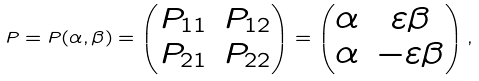Convert formula to latex. <formula><loc_0><loc_0><loc_500><loc_500>P = P ( \alpha , \beta ) = \begin{pmatrix} P _ { 1 1 } & P _ { 1 2 } \\ P _ { 2 1 } & P _ { 2 2 } \end{pmatrix} = \begin{pmatrix} \alpha & \varepsilon \beta \\ \alpha & - \varepsilon \beta \end{pmatrix} ,</formula> 